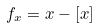Convert formula to latex. <formula><loc_0><loc_0><loc_500><loc_500>f _ { x } = x - [ x ]</formula> 